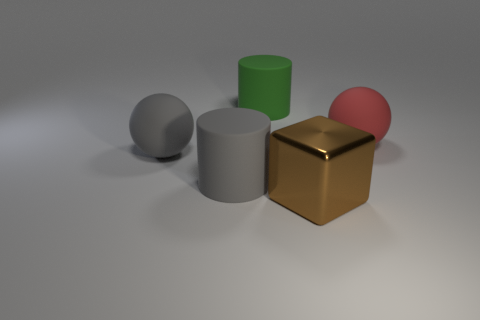Add 4 large blue shiny things. How many objects exist? 9 Subtract all blocks. How many objects are left? 4 Subtract all big blocks. Subtract all large green metallic cylinders. How many objects are left? 4 Add 5 big matte things. How many big matte things are left? 9 Add 4 gray shiny things. How many gray shiny things exist? 4 Subtract 0 yellow blocks. How many objects are left? 5 